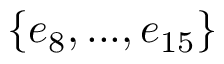<formula> <loc_0><loc_0><loc_500><loc_500>\{ e _ { 8 } , \dots , e _ { 1 5 } \}</formula> 